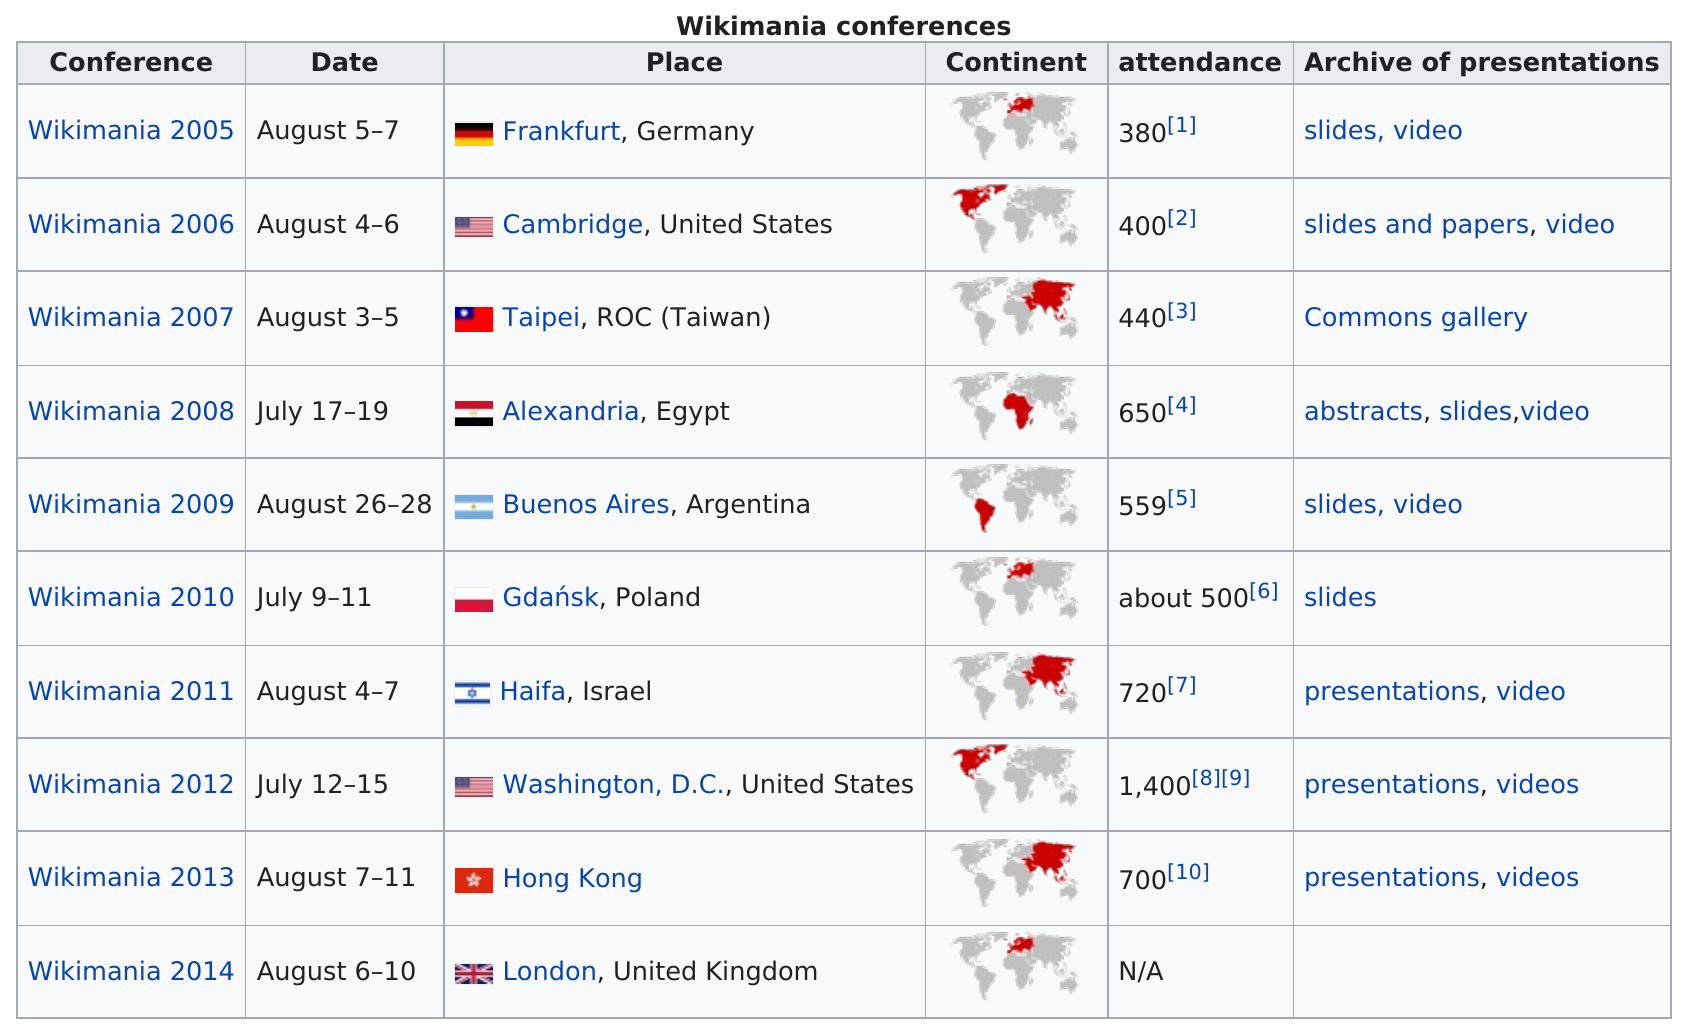Draw attention to some important aspects in this diagram. From 2005 to 2013, the Wikimania conference that was attended by the largest number of people was Wikimania 2012. In 2011, the attendance was either more or less than 700. The conference was held in Gdańsk, Poland, the year following Buenos Aires, Argentina. The Wikimania 2011 conference lasted for three days. Wikimania 2005 had the least number of attendees among all conferences. 